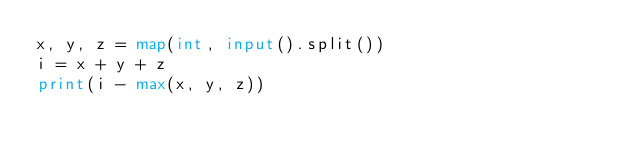Convert code to text. <code><loc_0><loc_0><loc_500><loc_500><_Python_>x, y, z = map(int, input().split())
i = x + y + z
print(i - max(x, y, z))
</code> 